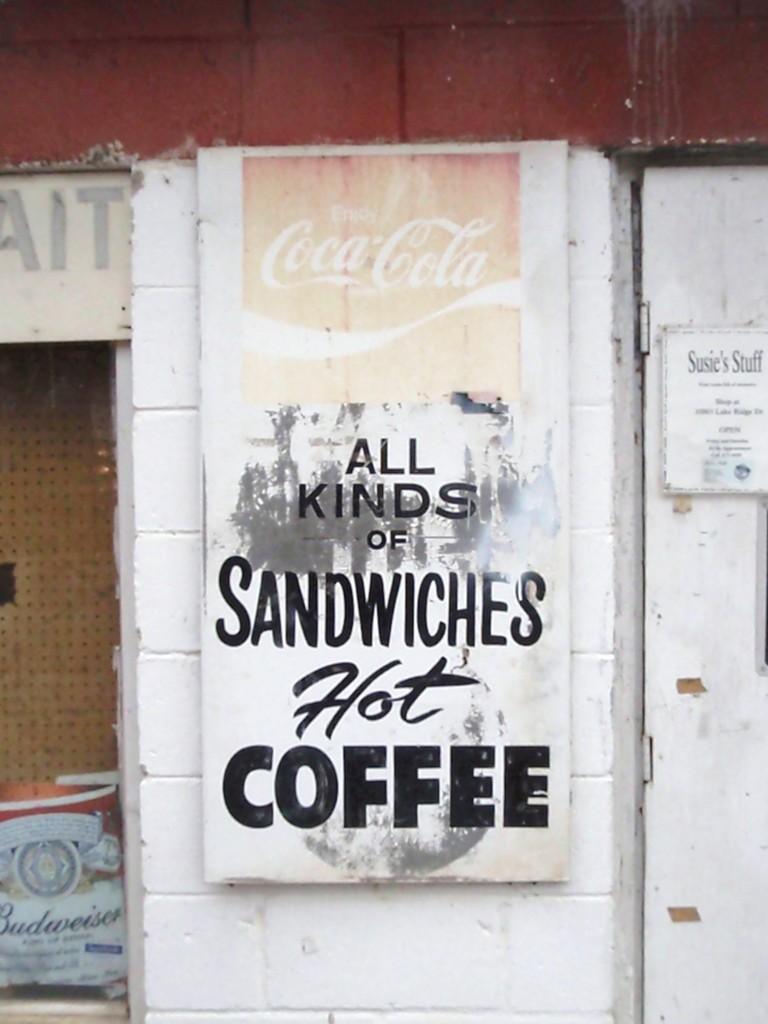In one or two sentences, can you explain what this image depicts? In this picture we can see a wall there is a board pasted on the wall, on the right side there is a door, we can see a paper pasted on the door. 